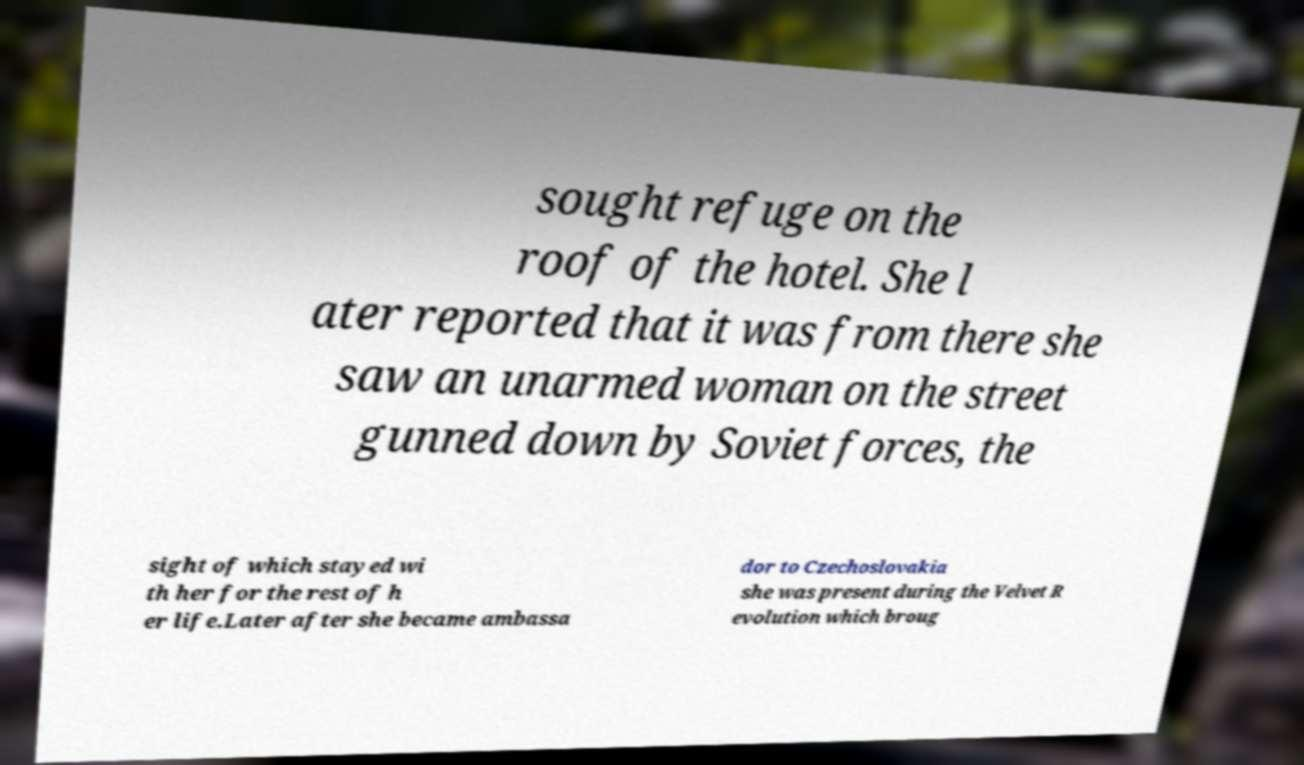Please read and relay the text visible in this image. What does it say? sought refuge on the roof of the hotel. She l ater reported that it was from there she saw an unarmed woman on the street gunned down by Soviet forces, the sight of which stayed wi th her for the rest of h er life.Later after she became ambassa dor to Czechoslovakia she was present during the Velvet R evolution which broug 